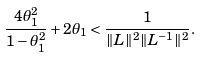Convert formula to latex. <formula><loc_0><loc_0><loc_500><loc_500>\frac { 4 \theta _ { 1 } ^ { 2 } } { 1 - \theta _ { 1 } ^ { 2 } } + 2 \theta _ { 1 } < \frac { 1 } { \| L \| ^ { 2 } \| L ^ { - 1 } \| ^ { 2 } } .</formula> 